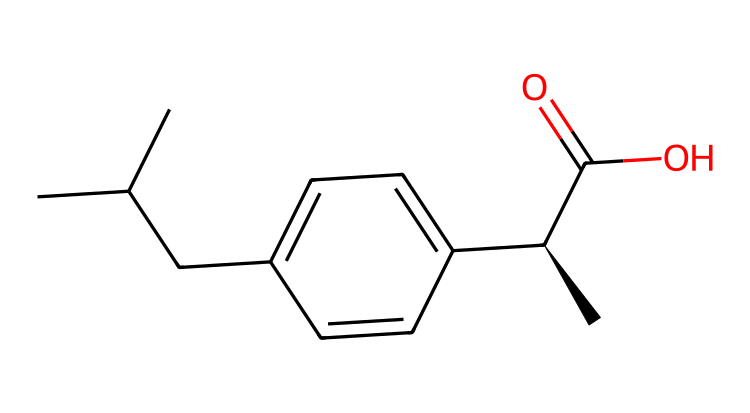What is the name of this chemical? The SMILES representation corresponds to ibuprofen, which is a commonly used non-steroidal anti-inflammatory drug (NSAID).
Answer: ibuprofen How many carbon atoms are in the structure? By analyzing the SMILES, we can count the carbon atoms represented by 'C' in the chain and rings. There are 13 carbon atoms in the structure.
Answer: 13 What is the functional group present in this chemical? The SMILES shows a carboxylic acid group (noted by ‘C(=O)O’) at the end of the structure, which indicates the presence of that functional group.
Answer: carboxylic acid Does this compound contain any stereocenters? In the SMILES, the '@' symbol denotes a stereocenter at the chiral carbon indicated by '[C@H]', confirming that this molecule has a stereocenter.
Answer: yes What is the molecular formula of ibuprofen based on this structure? To determine the molecular formula, we derive it from the counted elements: C13H18O2 for this compound, reflecting its composition accurately.
Answer: C13H18O2 Which part of the structure is responsible for its anti-inflammatory properties? The carboxylic acid group 'C(=O)O' is commonly associated with the pharmacological activity of ibuprofen, contributing to its anti-inflammatory effects.
Answer: carboxylic acid group What type of reaction does the presence of the carboxylic acid suggest for ibuprofen? The presence of the carboxylic acid suggests that ibuprofen can participate in acid-base reactions, often acting as an acid due to the hydrogen in the –COOH group.
Answer: acid-base reaction 